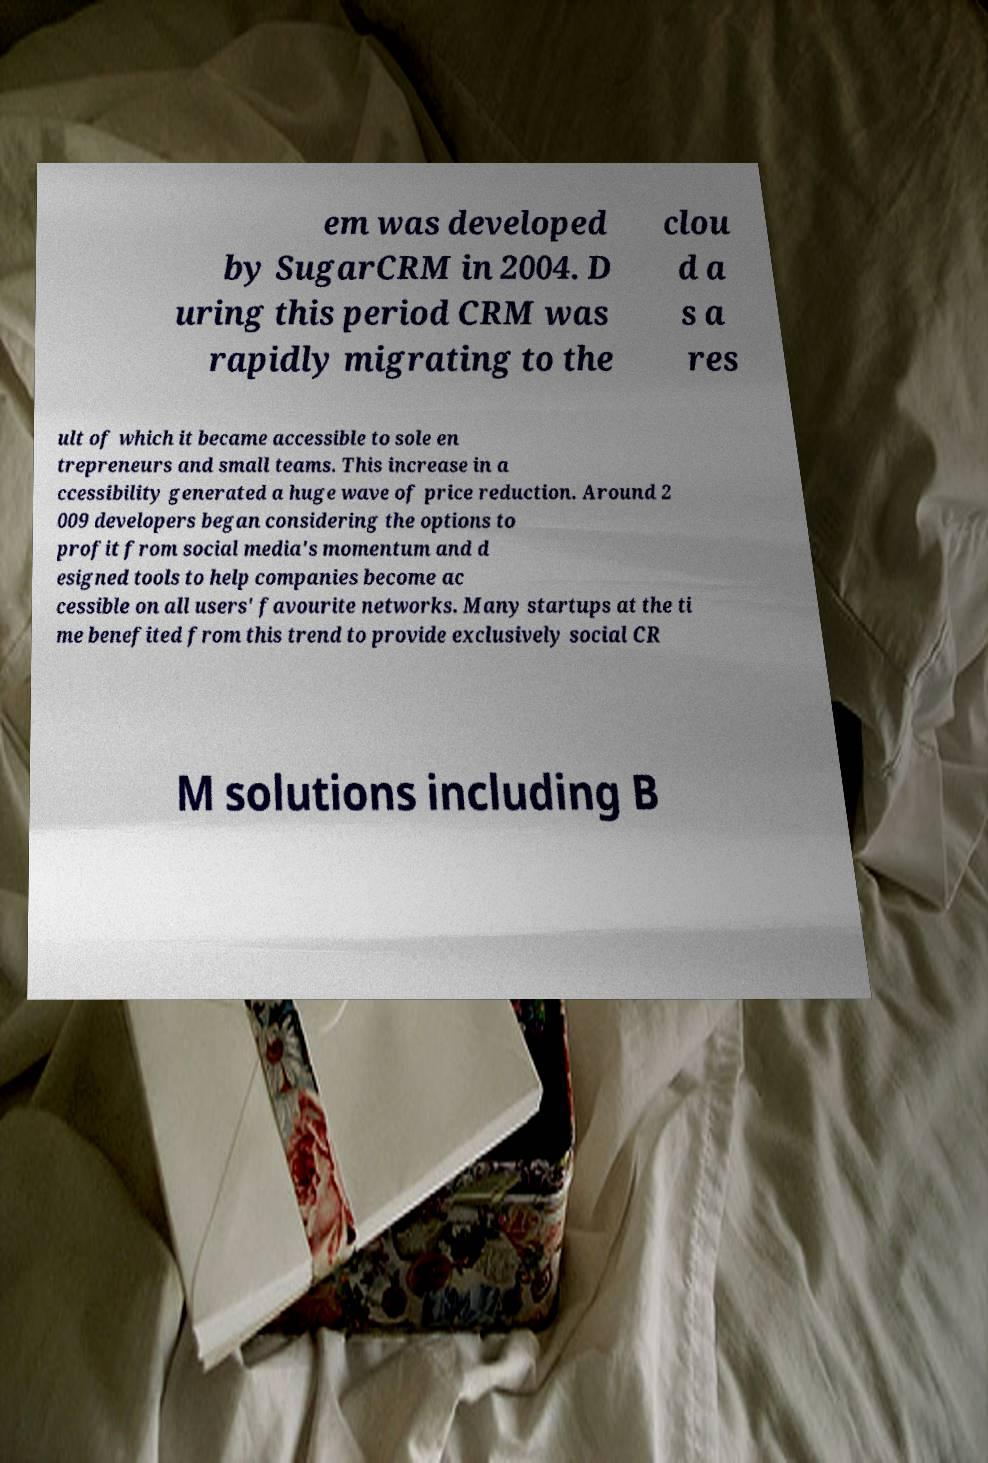Could you assist in decoding the text presented in this image and type it out clearly? em was developed by SugarCRM in 2004. D uring this period CRM was rapidly migrating to the clou d a s a res ult of which it became accessible to sole en trepreneurs and small teams. This increase in a ccessibility generated a huge wave of price reduction. Around 2 009 developers began considering the options to profit from social media's momentum and d esigned tools to help companies become ac cessible on all users' favourite networks. Many startups at the ti me benefited from this trend to provide exclusively social CR M solutions including B 